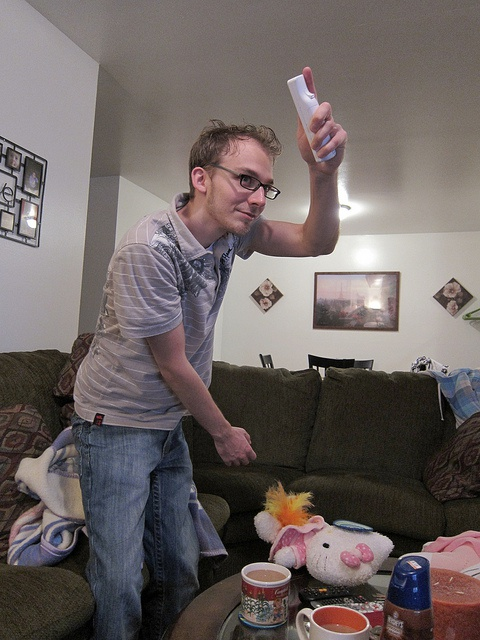Describe the objects in this image and their specific colors. I can see people in darkgray, gray, and black tones, couch in darkgray, black, and gray tones, teddy bear in darkgray, brown, and gray tones, cup in darkgray, gray, and maroon tones, and cup in darkgray and brown tones in this image. 